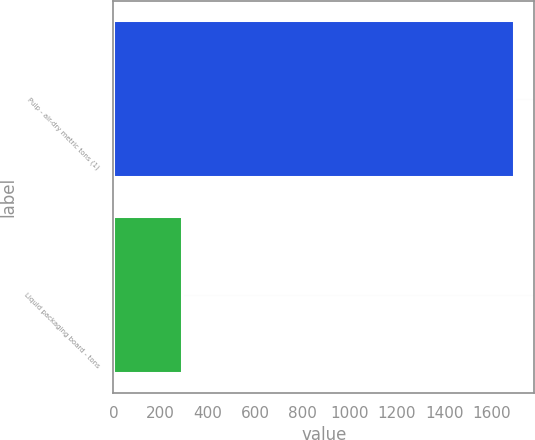<chart> <loc_0><loc_0><loc_500><loc_500><bar_chart><fcel>Pulp - air-dry metric tons (1)<fcel>Liquid packaging board - tons<nl><fcel>1697<fcel>288<nl></chart> 